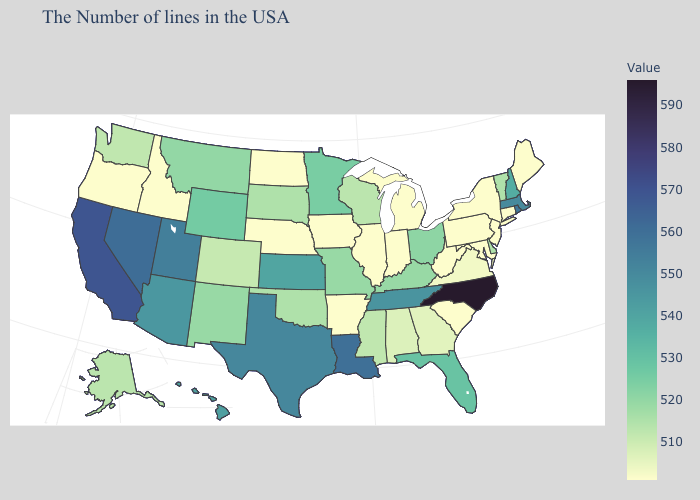Among the states that border North Dakota , does South Dakota have the lowest value?
Answer briefly. Yes. Which states have the highest value in the USA?
Concise answer only. North Carolina. Which states have the highest value in the USA?
Write a very short answer. North Carolina. Does Iowa have a lower value than Tennessee?
Short answer required. Yes. Which states have the lowest value in the USA?
Keep it brief. Maine, Connecticut, New York, New Jersey, Maryland, Pennsylvania, South Carolina, West Virginia, Michigan, Indiana, Illinois, Arkansas, Iowa, Nebraska, North Dakota, Idaho, Oregon. 